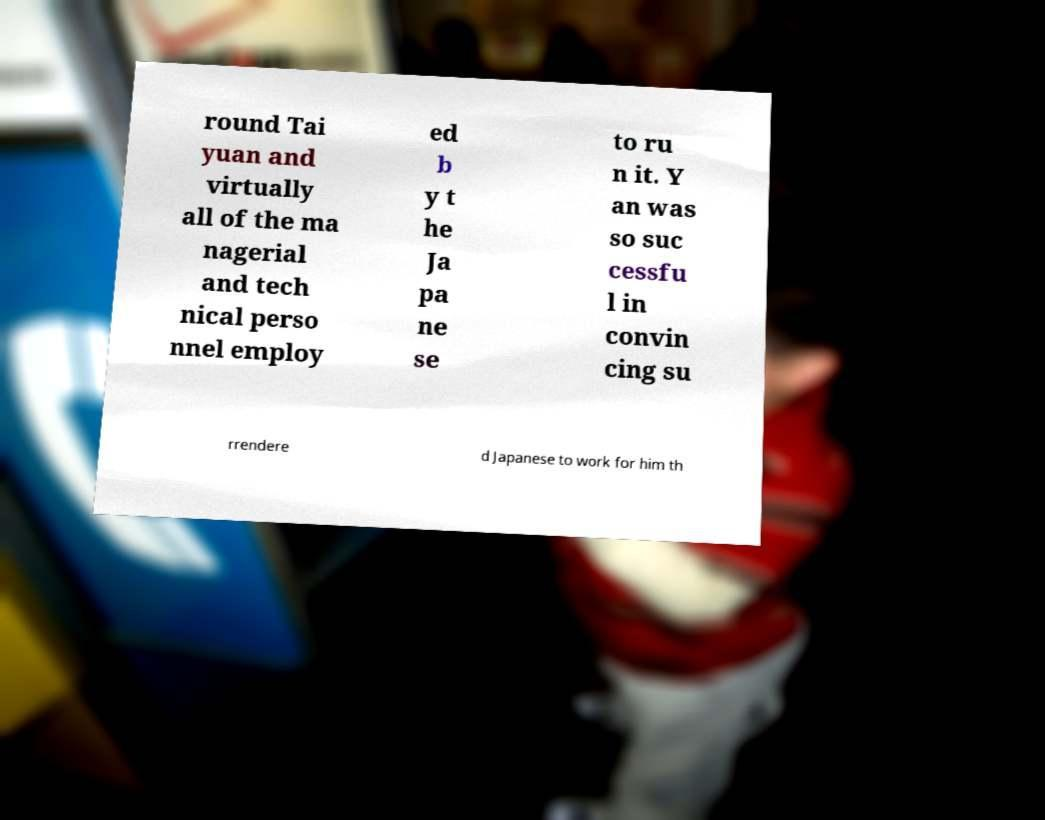Can you accurately transcribe the text from the provided image for me? round Tai yuan and virtually all of the ma nagerial and tech nical perso nnel employ ed b y t he Ja pa ne se to ru n it. Y an was so suc cessfu l in convin cing su rrendere d Japanese to work for him th 